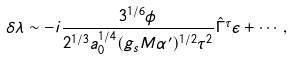Convert formula to latex. <formula><loc_0><loc_0><loc_500><loc_500>\delta \lambda \sim - i \frac { 3 ^ { 1 / 6 } \phi } { 2 ^ { 1 / 3 } a _ { 0 } ^ { 1 / 4 } ( g _ { s } M \alpha ^ { \prime } ) ^ { 1 / 2 } \tau ^ { 2 } } \hat { \Gamma } ^ { \tau } \epsilon + \cdots ,</formula> 